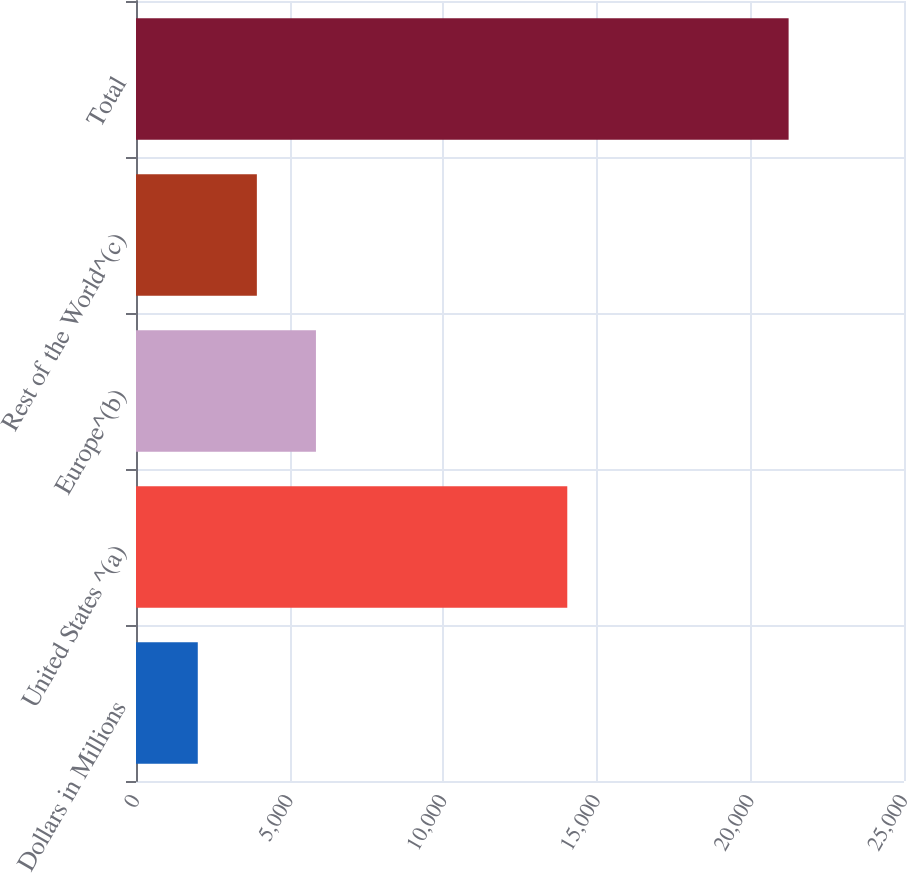Convert chart to OTSL. <chart><loc_0><loc_0><loc_500><loc_500><bar_chart><fcel>Dollars in Millions<fcel>United States ^(a)<fcel>Europe^(b)<fcel>Rest of the World^(c)<fcel>Total<nl><fcel>2011<fcel>14039<fcel>5857.6<fcel>3934.3<fcel>21244<nl></chart> 